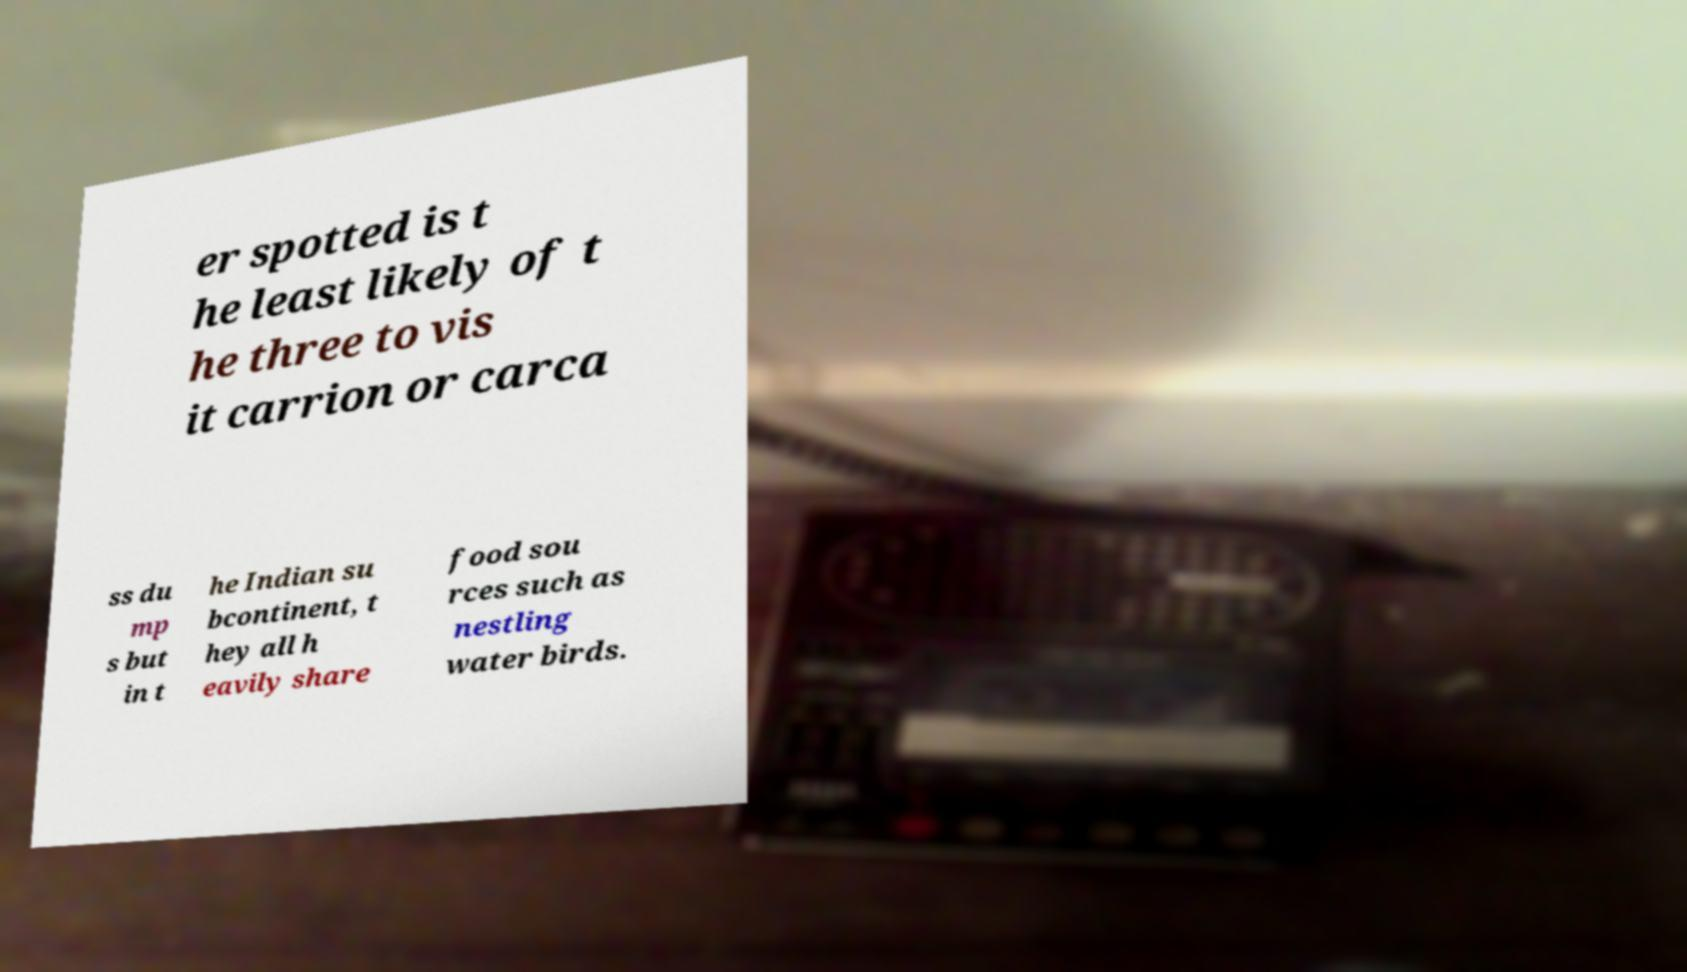Please identify and transcribe the text found in this image. er spotted is t he least likely of t he three to vis it carrion or carca ss du mp s but in t he Indian su bcontinent, t hey all h eavily share food sou rces such as nestling water birds. 